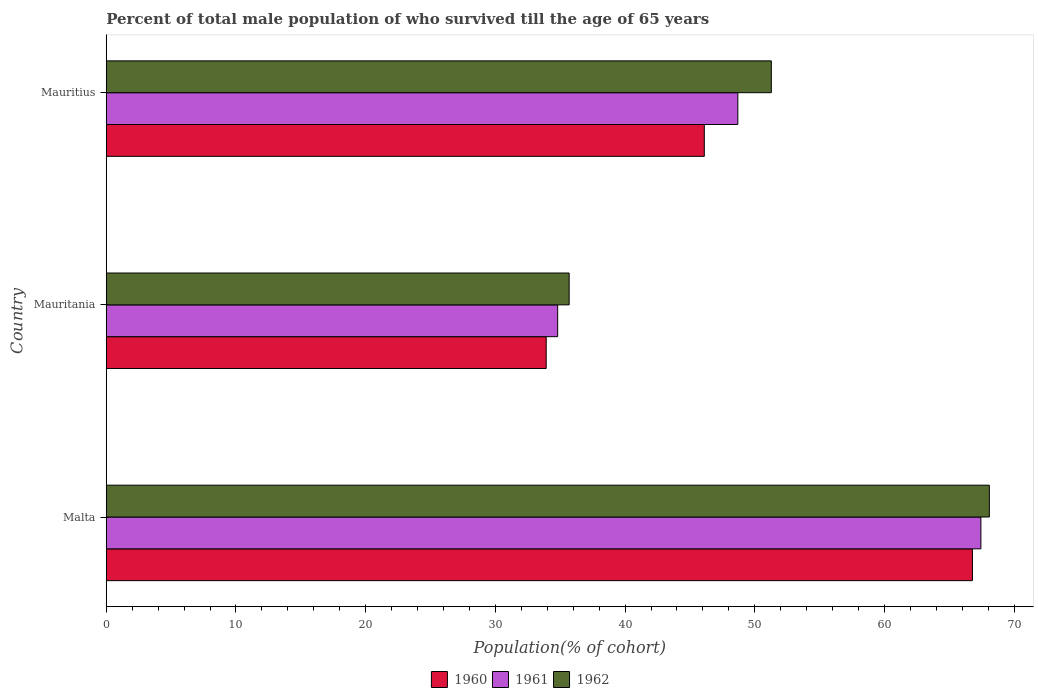Are the number of bars on each tick of the Y-axis equal?
Make the answer very short. Yes. How many bars are there on the 1st tick from the top?
Provide a short and direct response. 3. How many bars are there on the 2nd tick from the bottom?
Make the answer very short. 3. What is the label of the 1st group of bars from the top?
Provide a succinct answer. Mauritius. What is the percentage of total male population who survived till the age of 65 years in 1962 in Mauritius?
Offer a terse response. 51.27. Across all countries, what is the maximum percentage of total male population who survived till the age of 65 years in 1962?
Your answer should be very brief. 68.08. Across all countries, what is the minimum percentage of total male population who survived till the age of 65 years in 1960?
Give a very brief answer. 33.92. In which country was the percentage of total male population who survived till the age of 65 years in 1962 maximum?
Make the answer very short. Malta. In which country was the percentage of total male population who survived till the age of 65 years in 1960 minimum?
Your answer should be very brief. Mauritania. What is the total percentage of total male population who survived till the age of 65 years in 1961 in the graph?
Make the answer very short. 150.92. What is the difference between the percentage of total male population who survived till the age of 65 years in 1960 in Mauritania and that in Mauritius?
Offer a very short reply. -12.19. What is the difference between the percentage of total male population who survived till the age of 65 years in 1962 in Mauritania and the percentage of total male population who survived till the age of 65 years in 1960 in Malta?
Offer a very short reply. -31.09. What is the average percentage of total male population who survived till the age of 65 years in 1961 per country?
Ensure brevity in your answer.  50.31. What is the difference between the percentage of total male population who survived till the age of 65 years in 1962 and percentage of total male population who survived till the age of 65 years in 1961 in Mauritius?
Your response must be concise. 2.58. In how many countries, is the percentage of total male population who survived till the age of 65 years in 1960 greater than 26 %?
Make the answer very short. 3. What is the ratio of the percentage of total male population who survived till the age of 65 years in 1962 in Malta to that in Mauritius?
Offer a very short reply. 1.33. Is the percentage of total male population who survived till the age of 65 years in 1962 in Mauritania less than that in Mauritius?
Offer a very short reply. Yes. Is the difference between the percentage of total male population who survived till the age of 65 years in 1962 in Malta and Mauritania greater than the difference between the percentage of total male population who survived till the age of 65 years in 1961 in Malta and Mauritania?
Offer a terse response. No. What is the difference between the highest and the second highest percentage of total male population who survived till the age of 65 years in 1961?
Offer a terse response. 18.74. What is the difference between the highest and the lowest percentage of total male population who survived till the age of 65 years in 1961?
Provide a succinct answer. 32.63. Is it the case that in every country, the sum of the percentage of total male population who survived till the age of 65 years in 1960 and percentage of total male population who survived till the age of 65 years in 1962 is greater than the percentage of total male population who survived till the age of 65 years in 1961?
Provide a succinct answer. Yes. How many bars are there?
Give a very brief answer. 9. What is the difference between two consecutive major ticks on the X-axis?
Offer a very short reply. 10. Does the graph contain grids?
Keep it short and to the point. No. Where does the legend appear in the graph?
Offer a terse response. Bottom center. What is the title of the graph?
Provide a short and direct response. Percent of total male population of who survived till the age of 65 years. What is the label or title of the X-axis?
Give a very brief answer. Population(% of cohort). What is the label or title of the Y-axis?
Provide a succinct answer. Country. What is the Population(% of cohort) in 1960 in Malta?
Your answer should be compact. 66.78. What is the Population(% of cohort) in 1961 in Malta?
Keep it short and to the point. 67.43. What is the Population(% of cohort) of 1962 in Malta?
Make the answer very short. 68.08. What is the Population(% of cohort) in 1960 in Mauritania?
Keep it short and to the point. 33.92. What is the Population(% of cohort) of 1961 in Mauritania?
Offer a terse response. 34.8. What is the Population(% of cohort) of 1962 in Mauritania?
Your answer should be very brief. 35.69. What is the Population(% of cohort) of 1960 in Mauritius?
Offer a terse response. 46.11. What is the Population(% of cohort) of 1961 in Mauritius?
Offer a very short reply. 48.69. What is the Population(% of cohort) of 1962 in Mauritius?
Offer a terse response. 51.27. Across all countries, what is the maximum Population(% of cohort) in 1960?
Provide a short and direct response. 66.78. Across all countries, what is the maximum Population(% of cohort) in 1961?
Provide a succinct answer. 67.43. Across all countries, what is the maximum Population(% of cohort) in 1962?
Ensure brevity in your answer.  68.08. Across all countries, what is the minimum Population(% of cohort) of 1960?
Your response must be concise. 33.92. Across all countries, what is the minimum Population(% of cohort) in 1961?
Provide a short and direct response. 34.8. Across all countries, what is the minimum Population(% of cohort) in 1962?
Provide a short and direct response. 35.69. What is the total Population(% of cohort) of 1960 in the graph?
Make the answer very short. 146.8. What is the total Population(% of cohort) of 1961 in the graph?
Provide a short and direct response. 150.92. What is the total Population(% of cohort) in 1962 in the graph?
Make the answer very short. 155.04. What is the difference between the Population(% of cohort) in 1960 in Malta and that in Mauritania?
Offer a terse response. 32.86. What is the difference between the Population(% of cohort) of 1961 in Malta and that in Mauritania?
Provide a short and direct response. 32.63. What is the difference between the Population(% of cohort) in 1962 in Malta and that in Mauritania?
Offer a terse response. 32.39. What is the difference between the Population(% of cohort) in 1960 in Malta and that in Mauritius?
Keep it short and to the point. 20.67. What is the difference between the Population(% of cohort) of 1961 in Malta and that in Mauritius?
Offer a terse response. 18.74. What is the difference between the Population(% of cohort) of 1962 in Malta and that in Mauritius?
Keep it short and to the point. 16.81. What is the difference between the Population(% of cohort) of 1960 in Mauritania and that in Mauritius?
Ensure brevity in your answer.  -12.19. What is the difference between the Population(% of cohort) in 1961 in Mauritania and that in Mauritius?
Your response must be concise. -13.89. What is the difference between the Population(% of cohort) of 1962 in Mauritania and that in Mauritius?
Offer a terse response. -15.59. What is the difference between the Population(% of cohort) of 1960 in Malta and the Population(% of cohort) of 1961 in Mauritania?
Make the answer very short. 31.98. What is the difference between the Population(% of cohort) of 1960 in Malta and the Population(% of cohort) of 1962 in Mauritania?
Your answer should be very brief. 31.09. What is the difference between the Population(% of cohort) in 1961 in Malta and the Population(% of cohort) in 1962 in Mauritania?
Provide a succinct answer. 31.74. What is the difference between the Population(% of cohort) of 1960 in Malta and the Population(% of cohort) of 1961 in Mauritius?
Ensure brevity in your answer.  18.09. What is the difference between the Population(% of cohort) of 1960 in Malta and the Population(% of cohort) of 1962 in Mauritius?
Ensure brevity in your answer.  15.5. What is the difference between the Population(% of cohort) of 1961 in Malta and the Population(% of cohort) of 1962 in Mauritius?
Provide a short and direct response. 16.16. What is the difference between the Population(% of cohort) in 1960 in Mauritania and the Population(% of cohort) in 1961 in Mauritius?
Give a very brief answer. -14.77. What is the difference between the Population(% of cohort) in 1960 in Mauritania and the Population(% of cohort) in 1962 in Mauritius?
Your response must be concise. -17.36. What is the difference between the Population(% of cohort) of 1961 in Mauritania and the Population(% of cohort) of 1962 in Mauritius?
Offer a terse response. -16.47. What is the average Population(% of cohort) of 1960 per country?
Make the answer very short. 48.93. What is the average Population(% of cohort) in 1961 per country?
Provide a short and direct response. 50.31. What is the average Population(% of cohort) in 1962 per country?
Offer a terse response. 51.68. What is the difference between the Population(% of cohort) in 1960 and Population(% of cohort) in 1961 in Malta?
Your answer should be compact. -0.65. What is the difference between the Population(% of cohort) of 1960 and Population(% of cohort) of 1962 in Malta?
Your response must be concise. -1.3. What is the difference between the Population(% of cohort) of 1961 and Population(% of cohort) of 1962 in Malta?
Ensure brevity in your answer.  -0.65. What is the difference between the Population(% of cohort) of 1960 and Population(% of cohort) of 1961 in Mauritania?
Offer a very short reply. -0.88. What is the difference between the Population(% of cohort) of 1960 and Population(% of cohort) of 1962 in Mauritania?
Your response must be concise. -1.77. What is the difference between the Population(% of cohort) of 1961 and Population(% of cohort) of 1962 in Mauritania?
Offer a very short reply. -0.88. What is the difference between the Population(% of cohort) of 1960 and Population(% of cohort) of 1961 in Mauritius?
Give a very brief answer. -2.58. What is the difference between the Population(% of cohort) in 1960 and Population(% of cohort) in 1962 in Mauritius?
Provide a succinct answer. -5.17. What is the difference between the Population(% of cohort) of 1961 and Population(% of cohort) of 1962 in Mauritius?
Offer a very short reply. -2.58. What is the ratio of the Population(% of cohort) of 1960 in Malta to that in Mauritania?
Provide a succinct answer. 1.97. What is the ratio of the Population(% of cohort) in 1961 in Malta to that in Mauritania?
Your response must be concise. 1.94. What is the ratio of the Population(% of cohort) in 1962 in Malta to that in Mauritania?
Your answer should be compact. 1.91. What is the ratio of the Population(% of cohort) of 1960 in Malta to that in Mauritius?
Give a very brief answer. 1.45. What is the ratio of the Population(% of cohort) in 1961 in Malta to that in Mauritius?
Your answer should be compact. 1.38. What is the ratio of the Population(% of cohort) in 1962 in Malta to that in Mauritius?
Offer a terse response. 1.33. What is the ratio of the Population(% of cohort) in 1960 in Mauritania to that in Mauritius?
Offer a terse response. 0.74. What is the ratio of the Population(% of cohort) in 1961 in Mauritania to that in Mauritius?
Your response must be concise. 0.71. What is the ratio of the Population(% of cohort) in 1962 in Mauritania to that in Mauritius?
Your response must be concise. 0.7. What is the difference between the highest and the second highest Population(% of cohort) of 1960?
Provide a succinct answer. 20.67. What is the difference between the highest and the second highest Population(% of cohort) of 1961?
Offer a terse response. 18.74. What is the difference between the highest and the second highest Population(% of cohort) in 1962?
Provide a succinct answer. 16.81. What is the difference between the highest and the lowest Population(% of cohort) of 1960?
Ensure brevity in your answer.  32.86. What is the difference between the highest and the lowest Population(% of cohort) in 1961?
Make the answer very short. 32.63. What is the difference between the highest and the lowest Population(% of cohort) in 1962?
Provide a succinct answer. 32.39. 